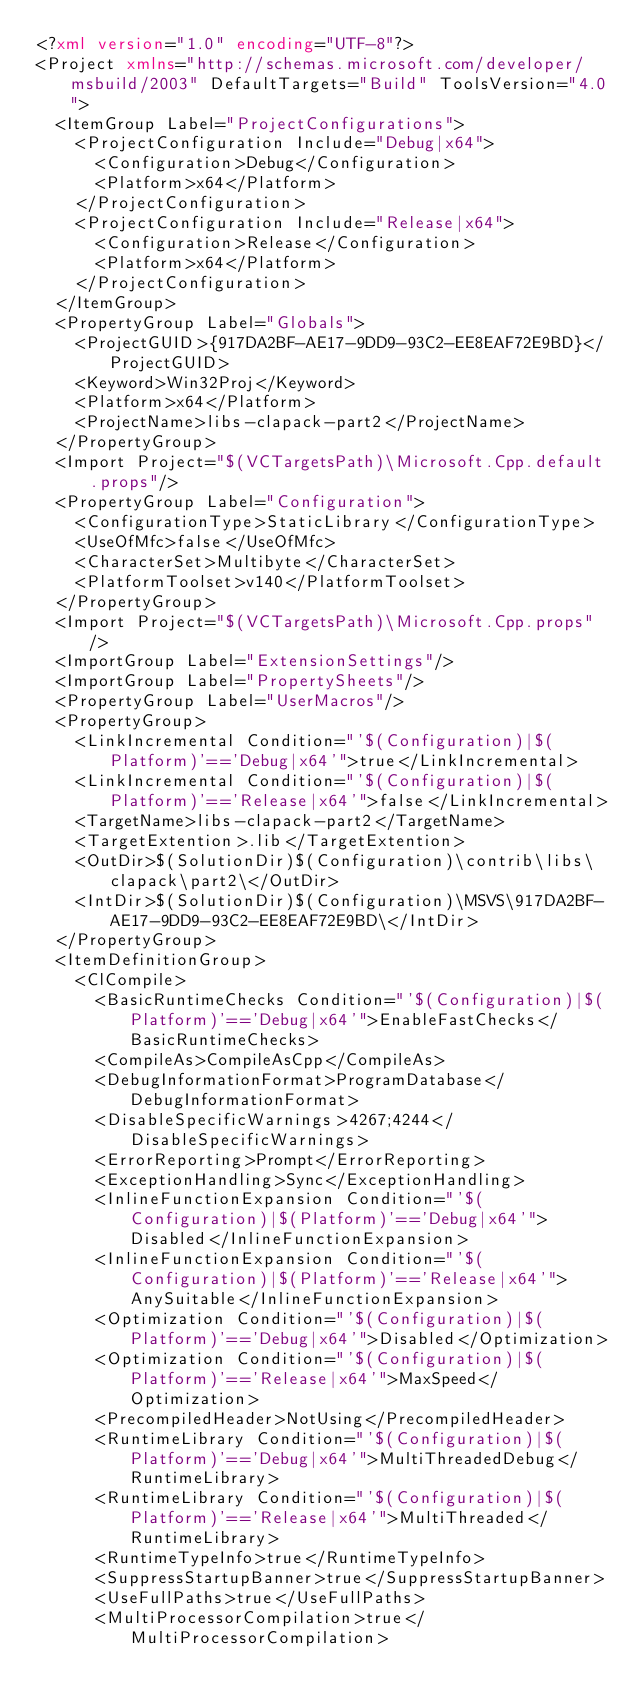Convert code to text. <code><loc_0><loc_0><loc_500><loc_500><_XML_><?xml version="1.0" encoding="UTF-8"?>
<Project xmlns="http://schemas.microsoft.com/developer/msbuild/2003" DefaultTargets="Build" ToolsVersion="4.0">
  <ItemGroup Label="ProjectConfigurations">
    <ProjectConfiguration Include="Debug|x64">
      <Configuration>Debug</Configuration>
      <Platform>x64</Platform>
    </ProjectConfiguration>
    <ProjectConfiguration Include="Release|x64">
      <Configuration>Release</Configuration>
      <Platform>x64</Platform>
    </ProjectConfiguration>
  </ItemGroup>
  <PropertyGroup Label="Globals">
    <ProjectGUID>{917DA2BF-AE17-9DD9-93C2-EE8EAF72E9BD}</ProjectGUID>
    <Keyword>Win32Proj</Keyword>
    <Platform>x64</Platform>
    <ProjectName>libs-clapack-part2</ProjectName>
  </PropertyGroup>
  <Import Project="$(VCTargetsPath)\Microsoft.Cpp.default.props"/>
  <PropertyGroup Label="Configuration">
    <ConfigurationType>StaticLibrary</ConfigurationType>
    <UseOfMfc>false</UseOfMfc>
    <CharacterSet>Multibyte</CharacterSet>
    <PlatformToolset>v140</PlatformToolset>
  </PropertyGroup>
  <Import Project="$(VCTargetsPath)\Microsoft.Cpp.props"/>
  <ImportGroup Label="ExtensionSettings"/>
  <ImportGroup Label="PropertySheets"/>
  <PropertyGroup Label="UserMacros"/>
  <PropertyGroup>
    <LinkIncremental Condition="'$(Configuration)|$(Platform)'=='Debug|x64'">true</LinkIncremental>
    <LinkIncremental Condition="'$(Configuration)|$(Platform)'=='Release|x64'">false</LinkIncremental>
    <TargetName>libs-clapack-part2</TargetName>
    <TargetExtention>.lib</TargetExtention>
    <OutDir>$(SolutionDir)$(Configuration)\contrib\libs\clapack\part2\</OutDir>
    <IntDir>$(SolutionDir)$(Configuration)\MSVS\917DA2BF-AE17-9DD9-93C2-EE8EAF72E9BD\</IntDir>
  </PropertyGroup>
  <ItemDefinitionGroup>
    <ClCompile>
      <BasicRuntimeChecks Condition="'$(Configuration)|$(Platform)'=='Debug|x64'">EnableFastChecks</BasicRuntimeChecks>
      <CompileAs>CompileAsCpp</CompileAs>
      <DebugInformationFormat>ProgramDatabase</DebugInformationFormat>
      <DisableSpecificWarnings>4267;4244</DisableSpecificWarnings>
      <ErrorReporting>Prompt</ErrorReporting>
      <ExceptionHandling>Sync</ExceptionHandling>
      <InlineFunctionExpansion Condition="'$(Configuration)|$(Platform)'=='Debug|x64'">Disabled</InlineFunctionExpansion>
      <InlineFunctionExpansion Condition="'$(Configuration)|$(Platform)'=='Release|x64'">AnySuitable</InlineFunctionExpansion>
      <Optimization Condition="'$(Configuration)|$(Platform)'=='Debug|x64'">Disabled</Optimization>
      <Optimization Condition="'$(Configuration)|$(Platform)'=='Release|x64'">MaxSpeed</Optimization>
      <PrecompiledHeader>NotUsing</PrecompiledHeader>
      <RuntimeLibrary Condition="'$(Configuration)|$(Platform)'=='Debug|x64'">MultiThreadedDebug</RuntimeLibrary>
      <RuntimeLibrary Condition="'$(Configuration)|$(Platform)'=='Release|x64'">MultiThreaded</RuntimeLibrary>
      <RuntimeTypeInfo>true</RuntimeTypeInfo>
      <SuppressStartupBanner>true</SuppressStartupBanner>
      <UseFullPaths>true</UseFullPaths>
      <MultiProcessorCompilation>true</MultiProcessorCompilation></code> 